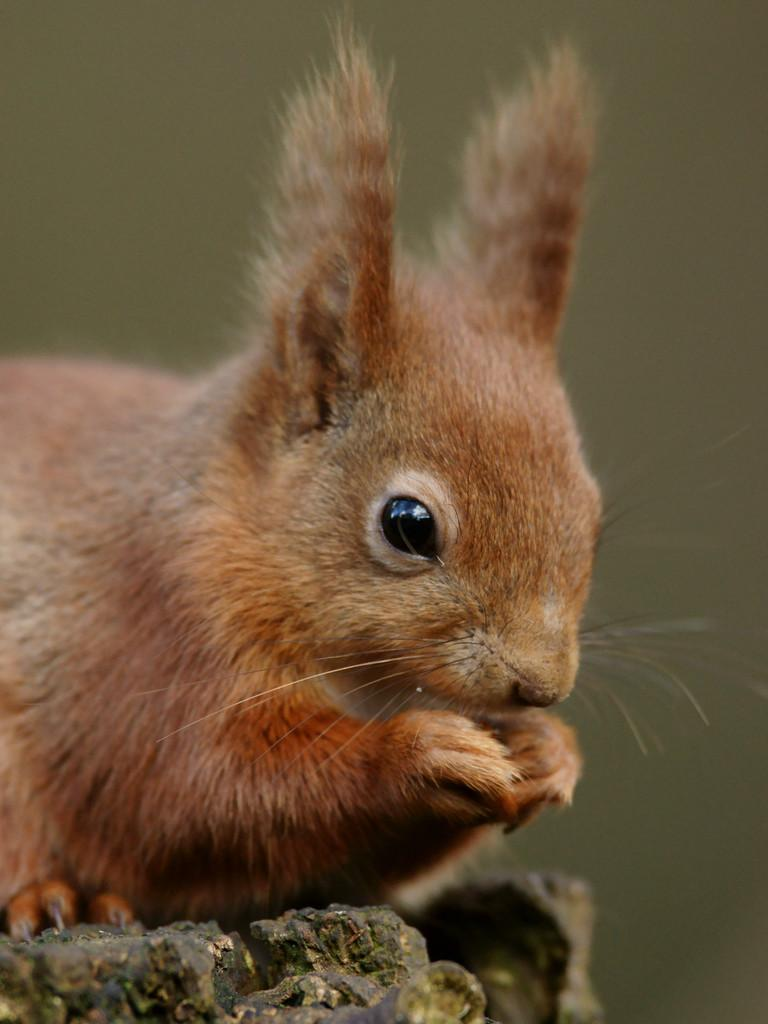What type of animal is in the image? There is a red squirrel in the image. Where is the red squirrel located? The red squirrel is on a wooden piece. Can you describe the background of the image? The background of the image is blurry. What type of brass instrument is the red squirrel playing in the image? There is no brass instrument present in the image; it features a red squirrel on a wooden piece with a blurry background. How many tomatoes can be seen in the image? There are no tomatoes present in the image. 